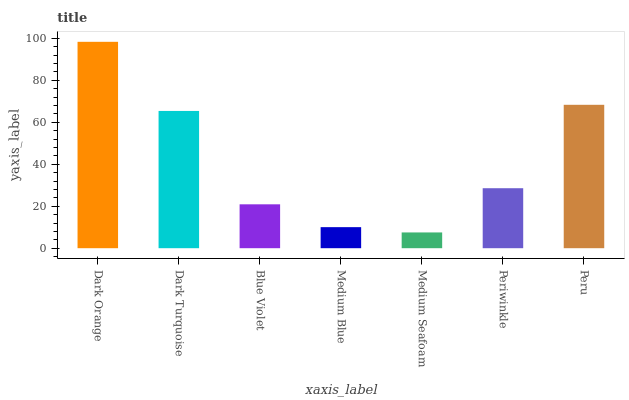Is Dark Turquoise the minimum?
Answer yes or no. No. Is Dark Turquoise the maximum?
Answer yes or no. No. Is Dark Orange greater than Dark Turquoise?
Answer yes or no. Yes. Is Dark Turquoise less than Dark Orange?
Answer yes or no. Yes. Is Dark Turquoise greater than Dark Orange?
Answer yes or no. No. Is Dark Orange less than Dark Turquoise?
Answer yes or no. No. Is Periwinkle the high median?
Answer yes or no. Yes. Is Periwinkle the low median?
Answer yes or no. Yes. Is Blue Violet the high median?
Answer yes or no. No. Is Blue Violet the low median?
Answer yes or no. No. 